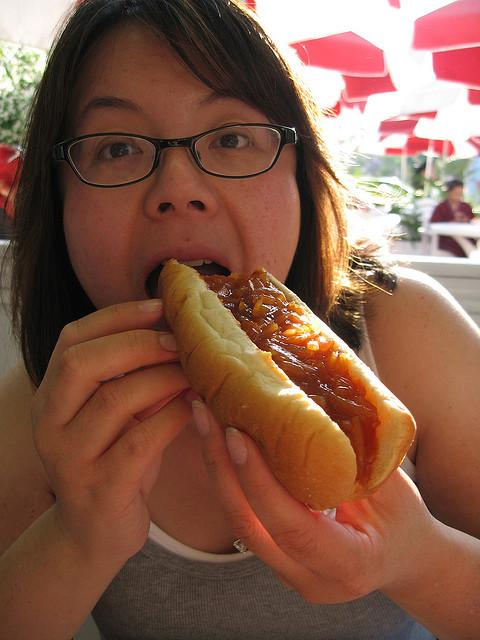What food is that bun normally used for?

Choices:
A) french fries
B) chicken strips
C) hot dogs
D) hamburgers hot dogs 